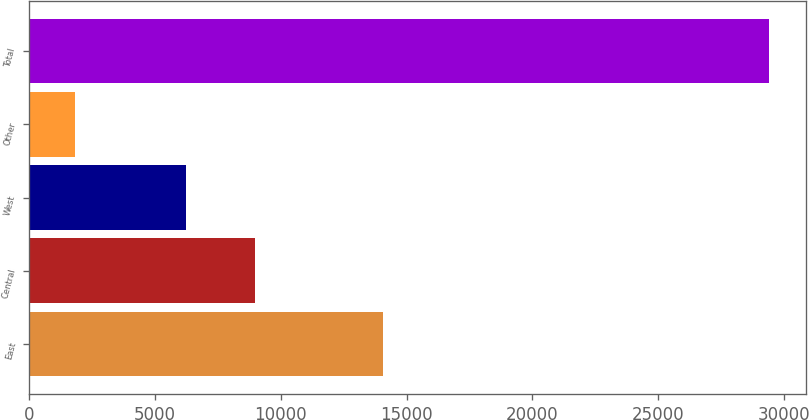<chart> <loc_0><loc_0><loc_500><loc_500><bar_chart><fcel>East<fcel>Central<fcel>West<fcel>Other<fcel>Total<nl><fcel>14076<fcel>8995.6<fcel>6238<fcel>1818<fcel>29394<nl></chart> 